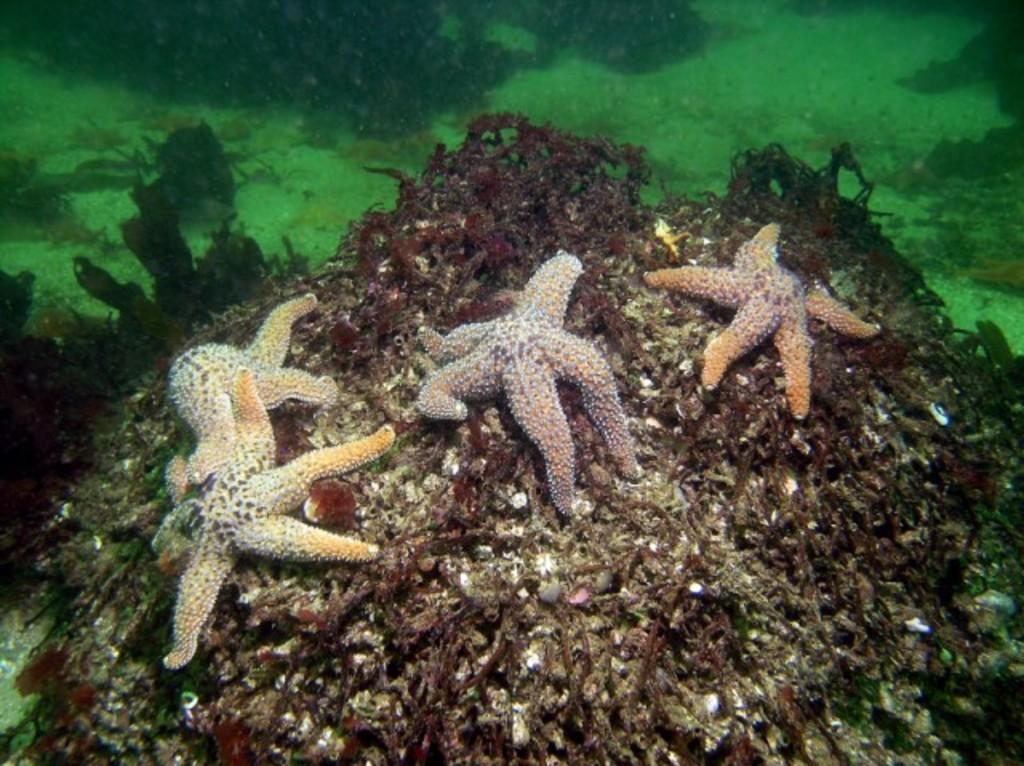Please provide a concise description of this image. As we can see in the image there is water and aquatic animals. 